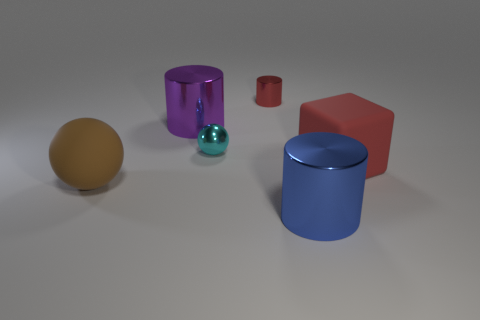Add 1 red blocks. How many objects exist? 7 Subtract all blocks. How many objects are left? 5 Subtract 0 cyan cubes. How many objects are left? 6 Subtract all small red metallic cylinders. Subtract all tiny shiny things. How many objects are left? 3 Add 5 tiny cyan metallic objects. How many tiny cyan metallic objects are left? 6 Add 3 rubber blocks. How many rubber blocks exist? 4 